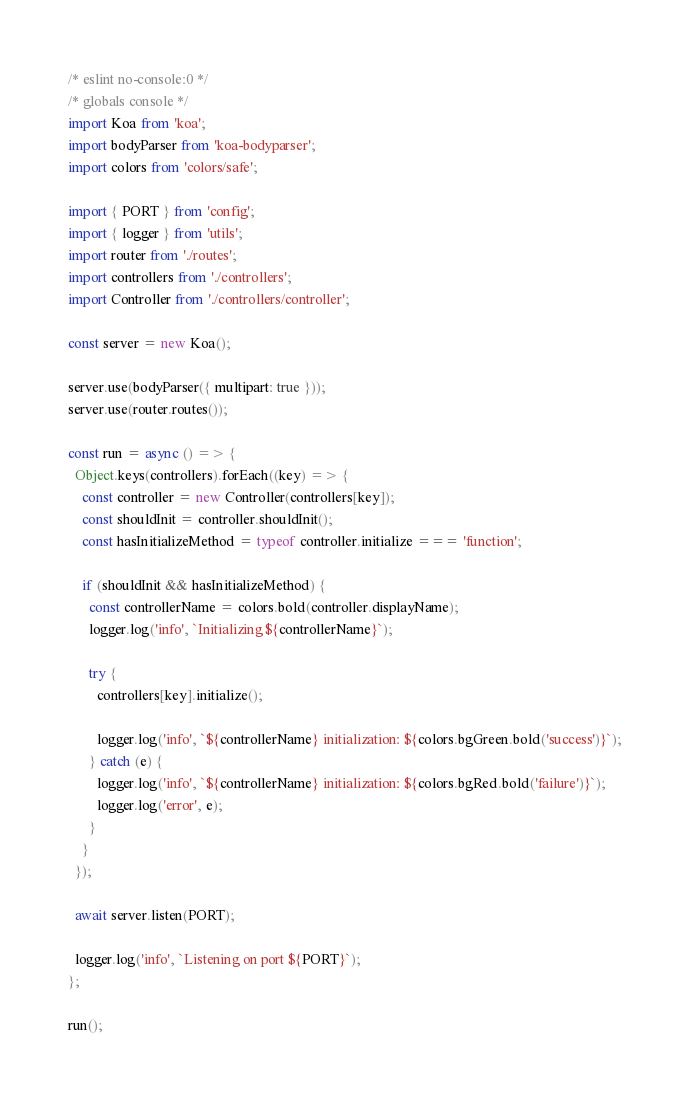<code> <loc_0><loc_0><loc_500><loc_500><_JavaScript_>/* eslint no-console:0 */
/* globals console */
import Koa from 'koa';
import bodyParser from 'koa-bodyparser';
import colors from 'colors/safe';

import { PORT } from 'config';
import { logger } from 'utils';
import router from './routes';
import controllers from './controllers';
import Controller from './controllers/controller';

const server = new Koa();

server.use(bodyParser({ multipart: true }));
server.use(router.routes());

const run = async () => {
  Object.keys(controllers).forEach((key) => {
    const controller = new Controller(controllers[key]);
    const shouldInit = controller.shouldInit();
    const hasInitializeMethod = typeof controller.initialize === 'function';

    if (shouldInit && hasInitializeMethod) {
      const controllerName = colors.bold(controller.displayName);
      logger.log('info', `Initializing ${controllerName}`);

      try {
        controllers[key].initialize();

        logger.log('info', `${controllerName} initialization: ${colors.bgGreen.bold('success')}`);
      } catch (e) {
        logger.log('info', `${controllerName} initialization: ${colors.bgRed.bold('failure')}`);
        logger.log('error', e);
      }
    }
  });

  await server.listen(PORT);

  logger.log('info', `Listening on port ${PORT}`);
};

run();
</code> 